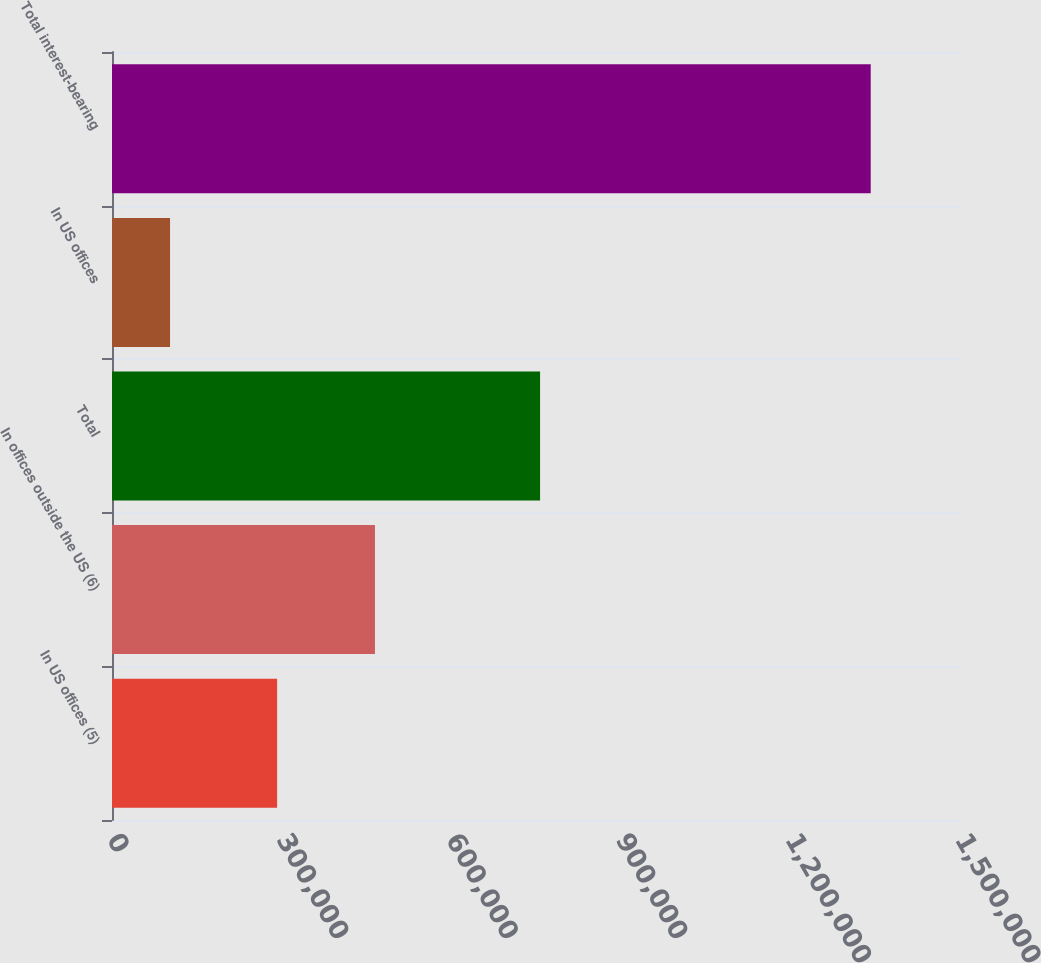<chart> <loc_0><loc_0><loc_500><loc_500><bar_chart><fcel>In US offices (5)<fcel>In offices outside the US (6)<fcel>Total<fcel>In US offices<fcel>Total interest-bearing<nl><fcel>292062<fcel>465135<fcel>757197<fcel>102672<fcel>1.34208e+06<nl></chart> 